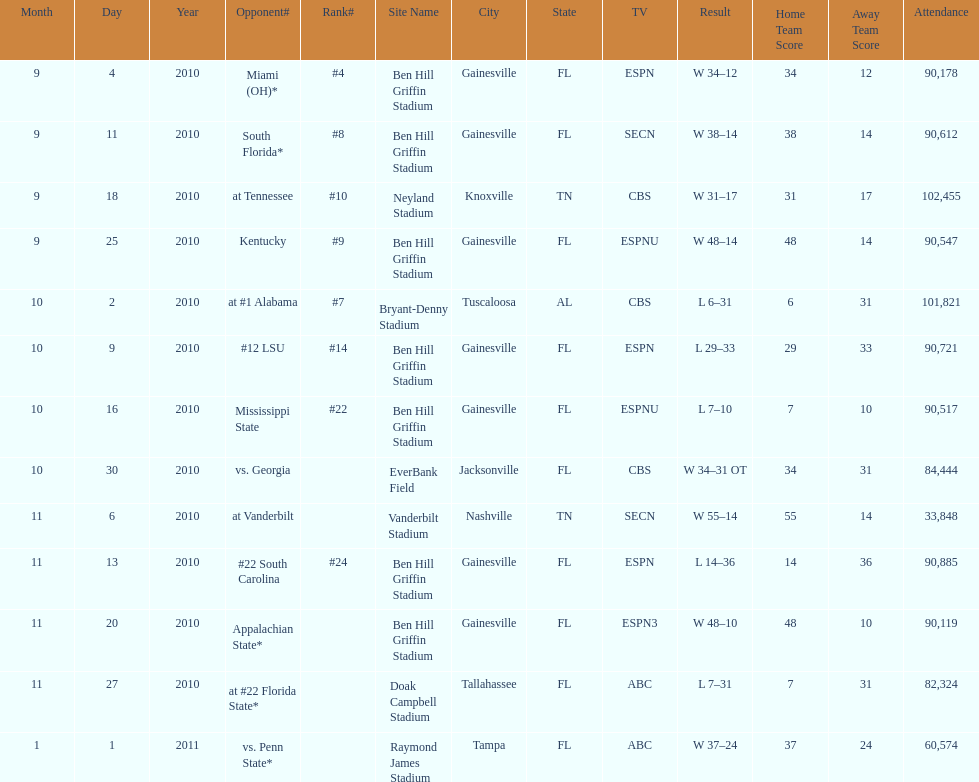What tv network showed the largest number of games during the 2010/2011 season? ESPN. 